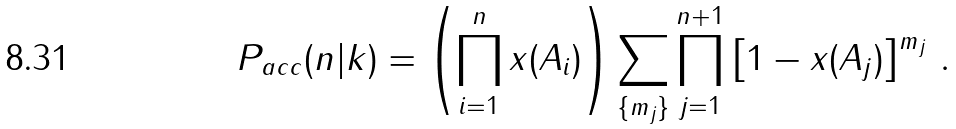Convert formula to latex. <formula><loc_0><loc_0><loc_500><loc_500>P _ { a c c } ( n | k ) = \left ( \prod _ { i = 1 } ^ { n } x ( A _ { i } ) \right ) \sum _ { \{ m _ { j } \} } \prod _ { j = 1 } ^ { n + 1 } \left [ 1 - x ( A _ { j } ) \right ] ^ { m _ { j } } \, .</formula> 